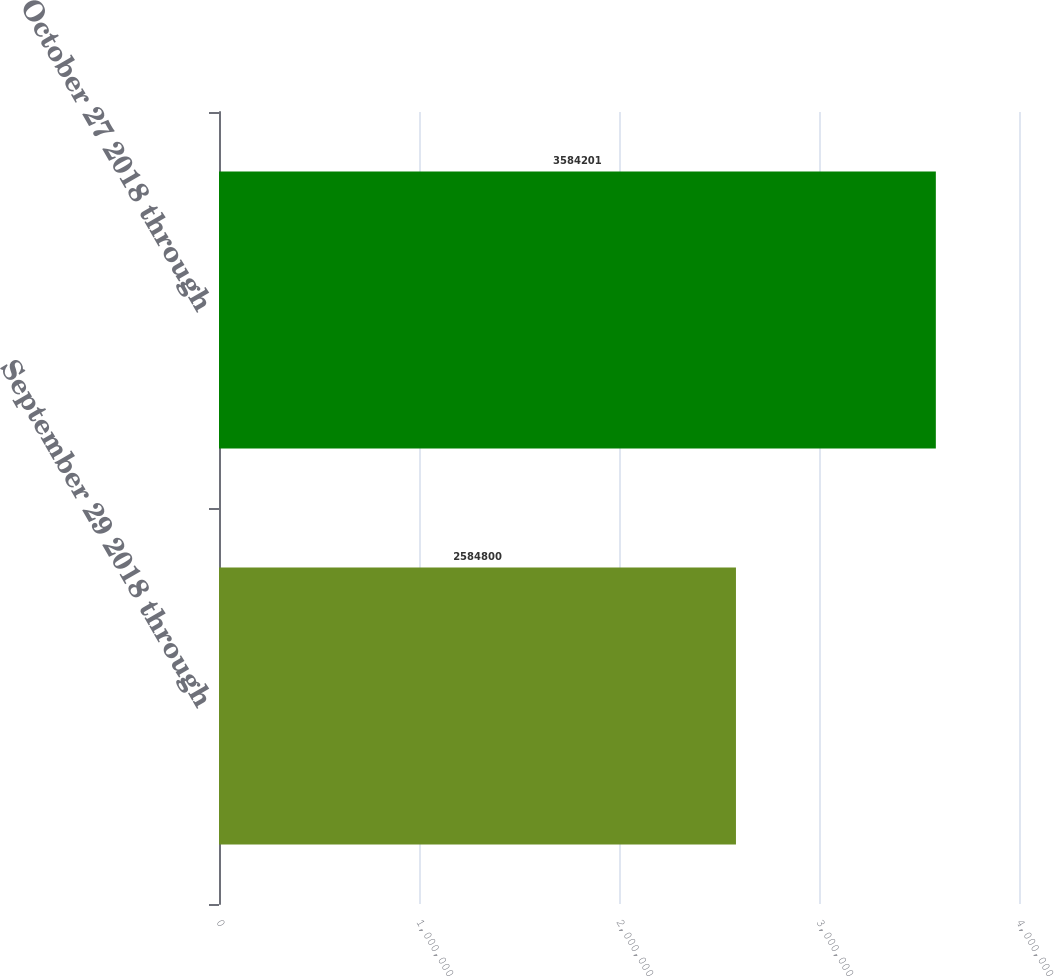<chart> <loc_0><loc_0><loc_500><loc_500><bar_chart><fcel>September 29 2018 through<fcel>October 27 2018 through<nl><fcel>2.5848e+06<fcel>3.5842e+06<nl></chart> 